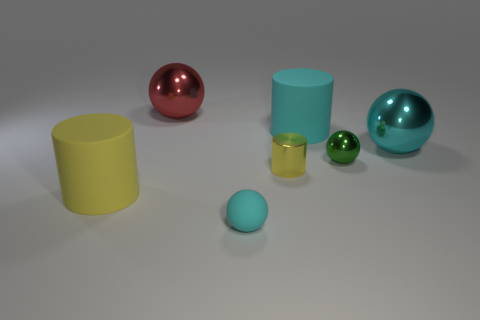How many cyan rubber balls are the same size as the red ball?
Make the answer very short. 0. What color is the other large thing that is the same material as the red object?
Your response must be concise. Cyan. Are there fewer metallic cylinders that are to the right of the rubber ball than cyan rubber cylinders?
Offer a very short reply. No. There is a small green thing that is the same material as the small yellow cylinder; what is its shape?
Offer a very short reply. Sphere. How many shiny things are either big cyan spheres or small cylinders?
Your response must be concise. 2. Are there an equal number of metal objects behind the red shiny thing and green objects?
Give a very brief answer. No. Is the color of the large rubber thing right of the large yellow thing the same as the tiny metallic cylinder?
Give a very brief answer. No. What is the cylinder that is in front of the big cyan rubber cylinder and behind the large yellow rubber object made of?
Provide a succinct answer. Metal. There is a big cylinder that is right of the small yellow cylinder; are there any metallic balls that are on the right side of it?
Make the answer very short. Yes. Are the tiny cyan object and the green sphere made of the same material?
Keep it short and to the point. No. 